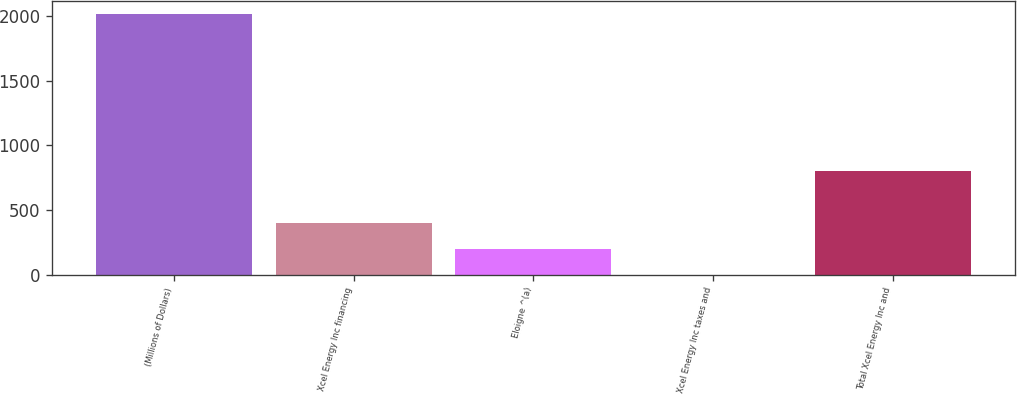Convert chart. <chart><loc_0><loc_0><loc_500><loc_500><bar_chart><fcel>(Millions of Dollars)<fcel>Xcel Energy Inc financing<fcel>Eloigne ^(a)<fcel>Xcel Energy Inc taxes and<fcel>Total Xcel Energy Inc and<nl><fcel>2011<fcel>402.68<fcel>201.64<fcel>0.6<fcel>804.76<nl></chart> 